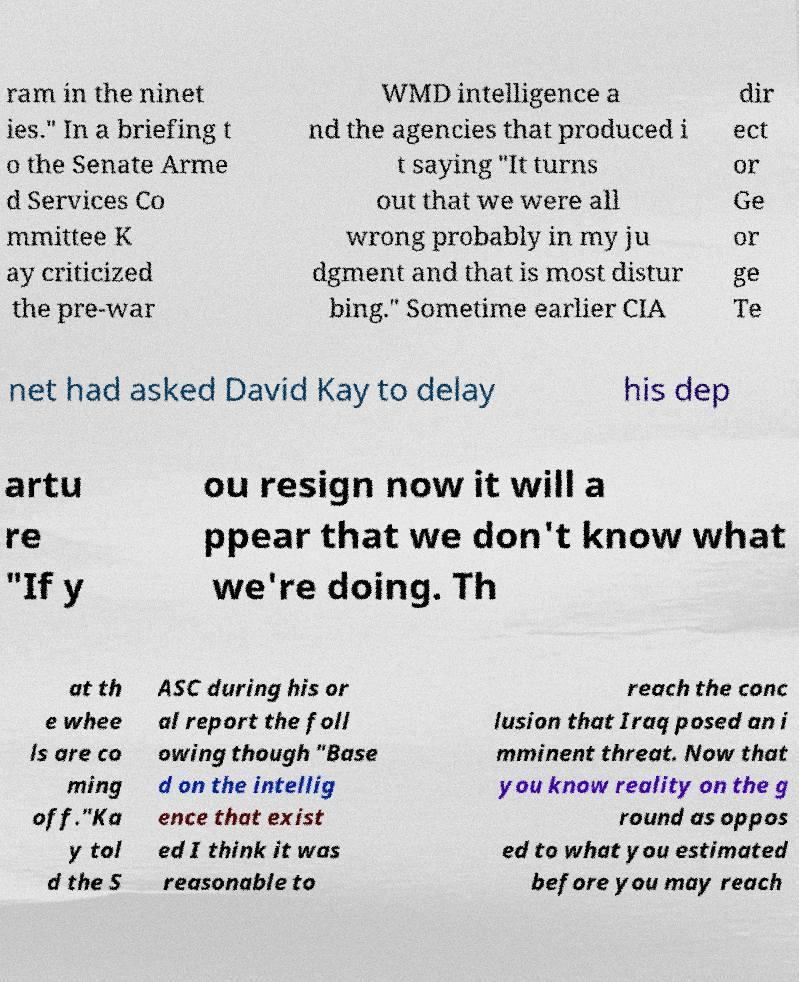Please identify and transcribe the text found in this image. ram in the ninet ies." In a briefing t o the Senate Arme d Services Co mmittee K ay criticized the pre-war WMD intelligence a nd the agencies that produced i t saying "It turns out that we were all wrong probably in my ju dgment and that is most distur bing." Sometime earlier CIA dir ect or Ge or ge Te net had asked David Kay to delay his dep artu re "If y ou resign now it will a ppear that we don't know what we're doing. Th at th e whee ls are co ming off."Ka y tol d the S ASC during his or al report the foll owing though "Base d on the intellig ence that exist ed I think it was reasonable to reach the conc lusion that Iraq posed an i mminent threat. Now that you know reality on the g round as oppos ed to what you estimated before you may reach 